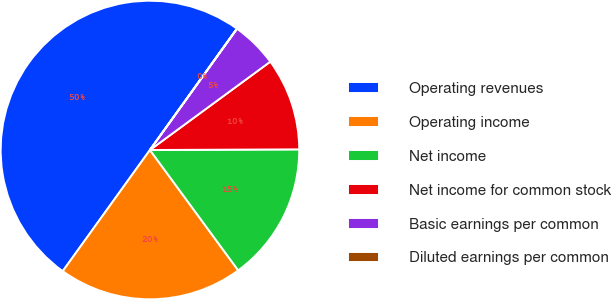Convert chart to OTSL. <chart><loc_0><loc_0><loc_500><loc_500><pie_chart><fcel>Operating revenues<fcel>Operating income<fcel>Net income<fcel>Net income for common stock<fcel>Basic earnings per common<fcel>Diluted earnings per common<nl><fcel>49.97%<fcel>20.0%<fcel>15.0%<fcel>10.01%<fcel>5.01%<fcel>0.02%<nl></chart> 